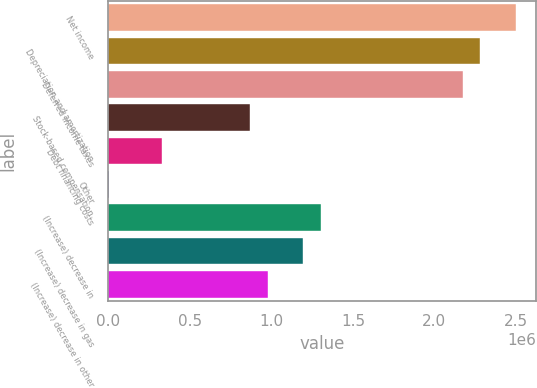<chart> <loc_0><loc_0><loc_500><loc_500><bar_chart><fcel>Net income<fcel>Depreciation and amortization<fcel>Deferred income taxes<fcel>Stock-based compensation<fcel>Debt financing costs<fcel>Other<fcel>(Increase) decrease in<fcel>(Increase) decrease in gas<fcel>(Increase) decrease in other<nl><fcel>2.49866e+06<fcel>2.28147e+06<fcel>2.17288e+06<fcel>869764<fcel>326798<fcel>1019<fcel>1.30414e+06<fcel>1.19554e+06<fcel>978357<nl></chart> 